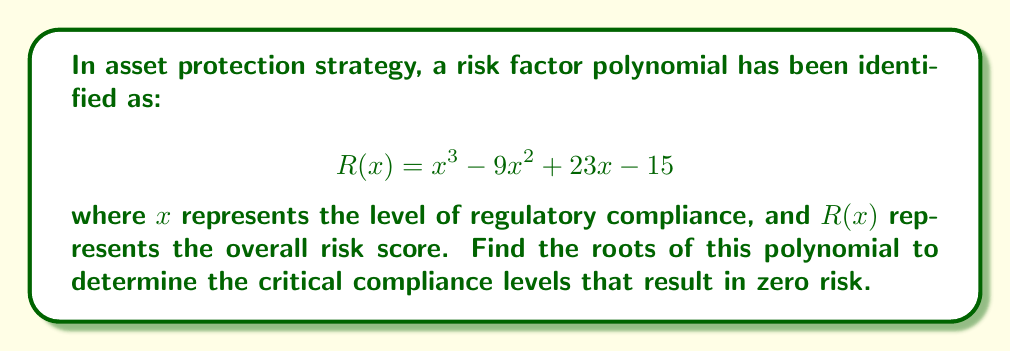Help me with this question. To find the roots of the polynomial $R(x) = x^3 - 9x^2 + 23x - 15$, we need to factor it. Let's approach this step-by-step:

1) First, let's check if there are any rational roots using the rational root theorem. The possible rational roots are the factors of the constant term (15): ±1, ±3, ±5, ±15.

2) Testing these values, we find that $R(1) = 0$. So, $(x-1)$ is a factor.

3) We can use polynomial long division to divide $R(x)$ by $(x-1)$:

   $$ x^3 - 9x^2 + 23x - 15 = (x-1)(x^2 - 8x + 15) $$

4) Now we need to factor the quadratic $x^2 - 8x + 15$. We can do this by finding two numbers that multiply to give 15 and add to give -8. These numbers are -3 and -5.

5) Therefore, $x^2 - 8x + 15 = (x-3)(x-5)$

6) Combining all factors, we get:

   $$ R(x) = (x-1)(x-3)(x-5) $$

Thus, the roots of the polynomial are 1, 3, and 5.

In the context of asset protection, these roots represent the critical compliance levels where the risk score becomes zero. These are important thresholds for a corporate lawyer to be aware of when developing asset protection strategies.
Answer: The roots of the polynomial are 1, 3, and 5. 